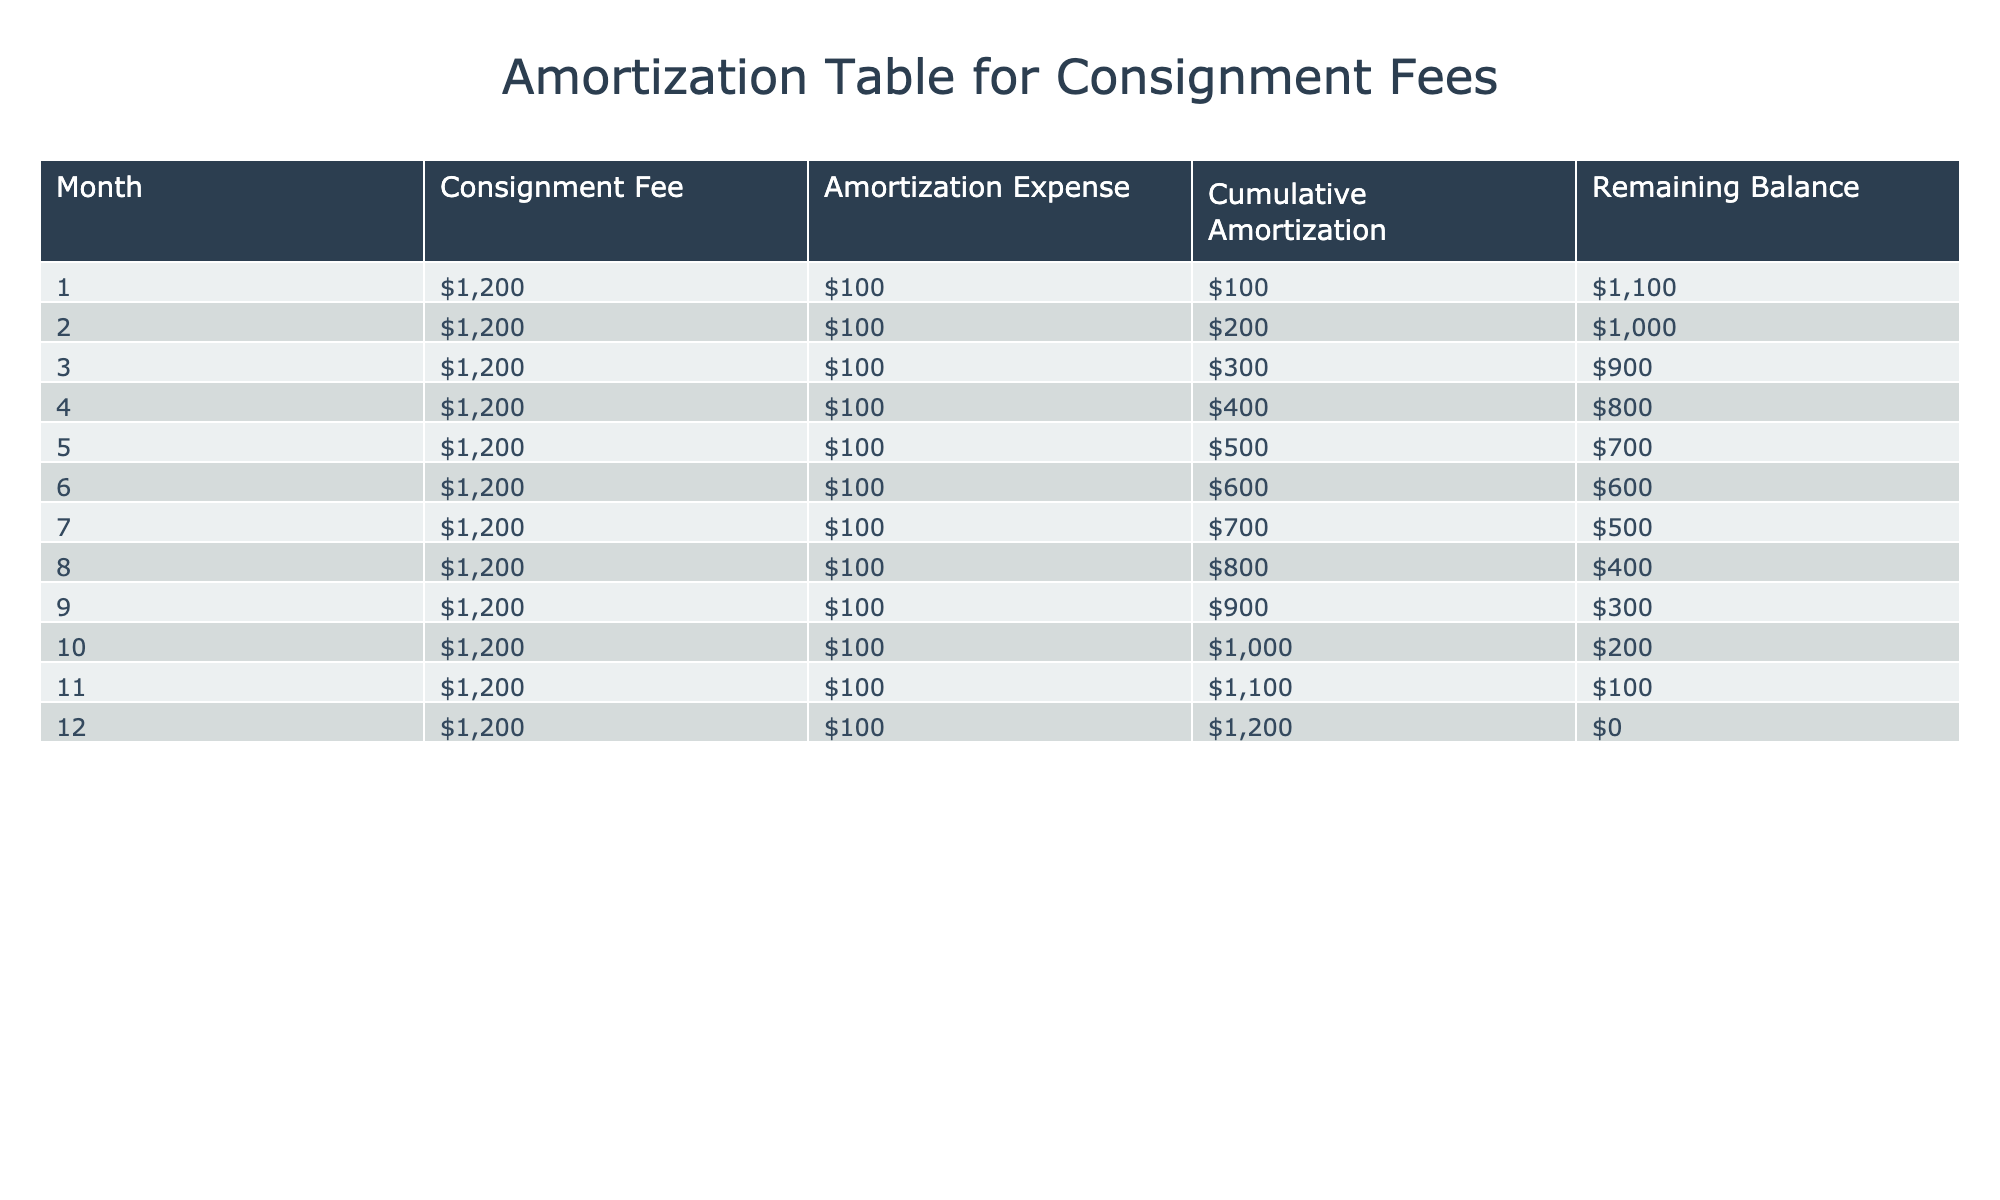What is the consignment fee for month 5? The consignment fee is provided in the table for each month. In month 5, it is listed specifically as 1200.
Answer: 1200 What is the cumulative amortization by the end of month 8? Cumulative amortization accumulates each month. By month 8, the cumulative amortization is 800 as shown in the table for that month.
Answer: 800 Is the remaining balance after month 10 less than 200? The remaining balance after month 10 is exactly 200, so it is not less than 200.
Answer: No What is the average amortization expense per month? The amortization expense is consistent across all months at 100. To find the average, we sum up the individual expenses and divide by the number of months: (100 * 12) / 12 = 100.
Answer: 100 What is the total consignment fee paid over 12 months? The consignment fee is 1200 each month for 12 months. The total can be calculated as 1200 * 12 = 14400.
Answer: 14400 What is the difference between the consignment fee for month 3 and month 11? The consignment fee for both month 3 and month 11 is 1200 each, so the difference is 1200 - 1200 = 0.
Answer: 0 By how much does the cumulative amortization increase from month 6 to month 9? Cumulative amortization in month 6 is 600, and in month 9 it is 900. The increase is calculated as 900 - 600 = 300.
Answer: 300 Is the remaining balance after month 12 zero? According to the table, the remaining balance after month 12 is listed as 0, confirming it is indeed zero.
Answer: Yes How many months it takes for the cumulative amortization to reach 1000? The cumulative amortization reaches 1000 at the end of month 10, as shown in the table.
Answer: 10 